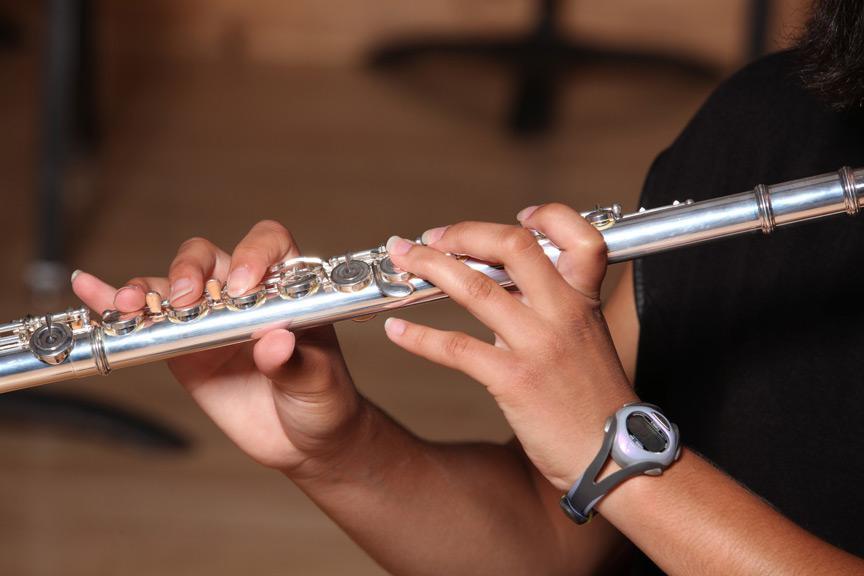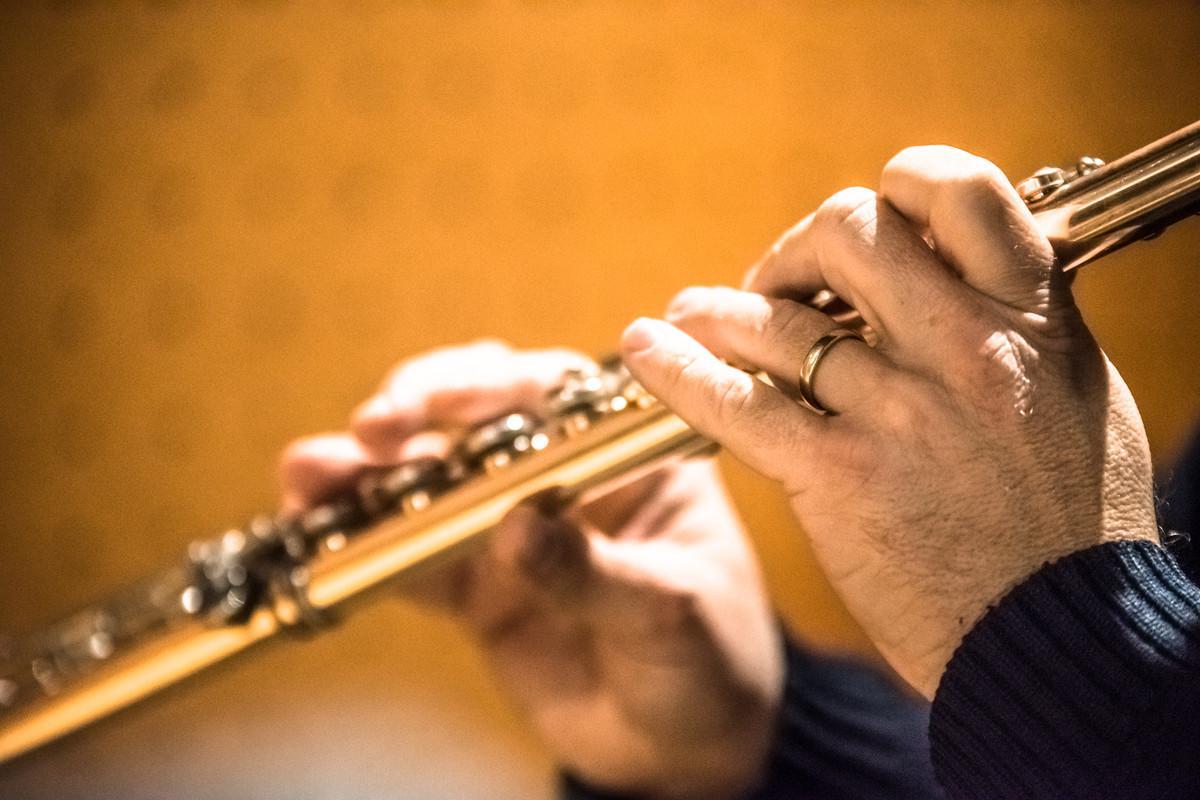The first image is the image on the left, the second image is the image on the right. For the images shown, is this caption "There are two flute being played and the end is facing left." true? Answer yes or no. Yes. The first image is the image on the left, the second image is the image on the right. For the images displayed, is the sentence "There are four hands." factually correct? Answer yes or no. Yes. 